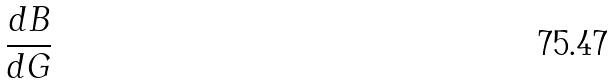Convert formula to latex. <formula><loc_0><loc_0><loc_500><loc_500>\frac { d B } { d G }</formula> 